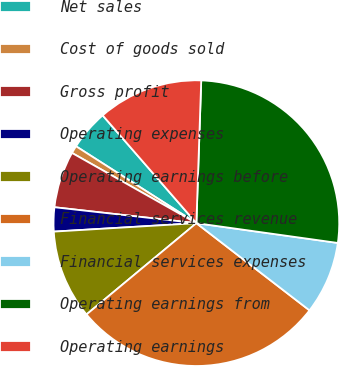Convert chart. <chart><loc_0><loc_0><loc_500><loc_500><pie_chart><fcel>Net sales<fcel>Cost of goods sold<fcel>Gross profit<fcel>Operating expenses<fcel>Operating earnings before<fcel>Financial services revenue<fcel>Financial services expenses<fcel>Operating earnings from<fcel>Operating earnings<nl><fcel>4.56%<fcel>0.87%<fcel>6.4%<fcel>2.72%<fcel>10.09%<fcel>28.51%<fcel>8.24%<fcel>26.67%<fcel>11.93%<nl></chart> 